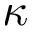<formula> <loc_0><loc_0><loc_500><loc_500>\kappa</formula> 